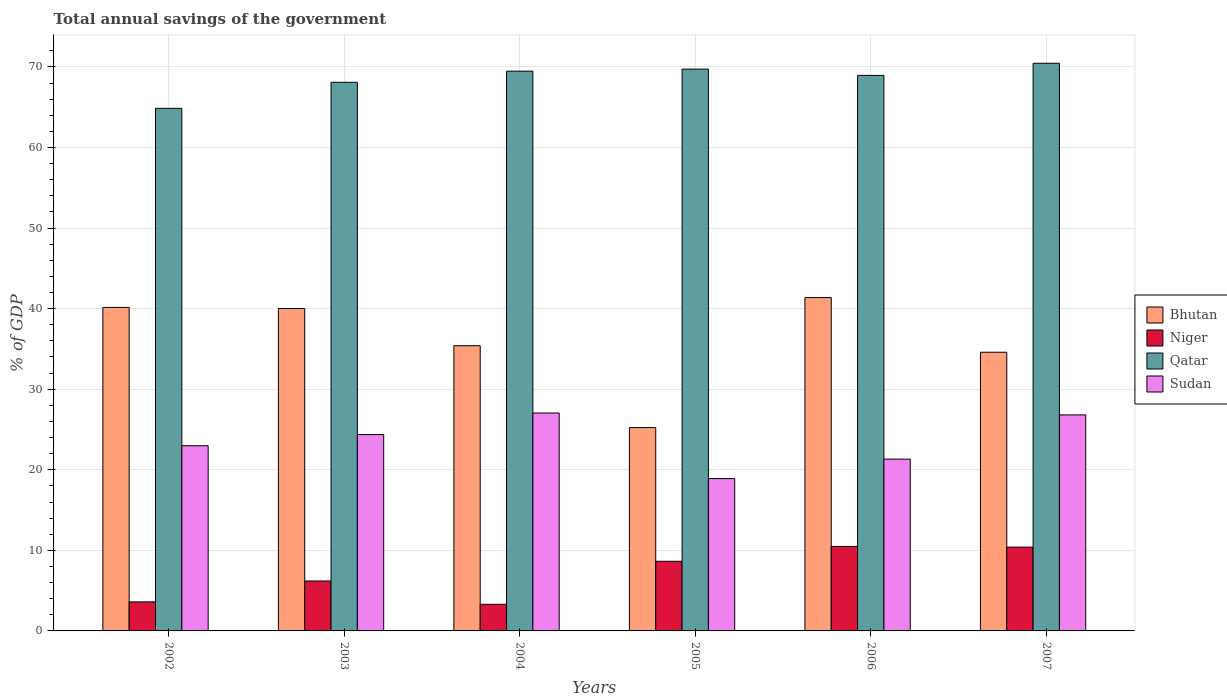Are the number of bars per tick equal to the number of legend labels?
Give a very brief answer. Yes. In how many cases, is the number of bars for a given year not equal to the number of legend labels?
Keep it short and to the point. 0. What is the total annual savings of the government in Bhutan in 2002?
Provide a short and direct response. 40.15. Across all years, what is the maximum total annual savings of the government in Niger?
Your response must be concise. 10.49. Across all years, what is the minimum total annual savings of the government in Qatar?
Keep it short and to the point. 64.86. In which year was the total annual savings of the government in Bhutan minimum?
Keep it short and to the point. 2005. What is the total total annual savings of the government in Niger in the graph?
Keep it short and to the point. 42.64. What is the difference between the total annual savings of the government in Sudan in 2002 and that in 2004?
Ensure brevity in your answer.  -4.06. What is the difference between the total annual savings of the government in Bhutan in 2007 and the total annual savings of the government in Sudan in 2003?
Offer a very short reply. 10.22. What is the average total annual savings of the government in Niger per year?
Keep it short and to the point. 7.11. In the year 2004, what is the difference between the total annual savings of the government in Sudan and total annual savings of the government in Bhutan?
Provide a short and direct response. -8.35. What is the ratio of the total annual savings of the government in Niger in 2004 to that in 2007?
Offer a very short reply. 0.32. Is the total annual savings of the government in Sudan in 2004 less than that in 2006?
Keep it short and to the point. No. Is the difference between the total annual savings of the government in Sudan in 2005 and 2007 greater than the difference between the total annual savings of the government in Bhutan in 2005 and 2007?
Offer a terse response. Yes. What is the difference between the highest and the second highest total annual savings of the government in Qatar?
Provide a succinct answer. 0.72. What is the difference between the highest and the lowest total annual savings of the government in Qatar?
Provide a succinct answer. 5.59. Is it the case that in every year, the sum of the total annual savings of the government in Niger and total annual savings of the government in Sudan is greater than the sum of total annual savings of the government in Qatar and total annual savings of the government in Bhutan?
Your response must be concise. No. What does the 3rd bar from the left in 2003 represents?
Give a very brief answer. Qatar. What does the 3rd bar from the right in 2004 represents?
Keep it short and to the point. Niger. How many bars are there?
Your answer should be compact. 24. Are all the bars in the graph horizontal?
Give a very brief answer. No. What is the difference between two consecutive major ticks on the Y-axis?
Ensure brevity in your answer.  10. How are the legend labels stacked?
Offer a very short reply. Vertical. What is the title of the graph?
Keep it short and to the point. Total annual savings of the government. Does "Mauritius" appear as one of the legend labels in the graph?
Your answer should be compact. No. What is the label or title of the Y-axis?
Your response must be concise. % of GDP. What is the % of GDP in Bhutan in 2002?
Ensure brevity in your answer.  40.15. What is the % of GDP of Niger in 2002?
Give a very brief answer. 3.6. What is the % of GDP in Qatar in 2002?
Keep it short and to the point. 64.86. What is the % of GDP in Sudan in 2002?
Offer a terse response. 22.98. What is the % of GDP in Bhutan in 2003?
Your answer should be compact. 40.01. What is the % of GDP in Niger in 2003?
Make the answer very short. 6.2. What is the % of GDP of Qatar in 2003?
Ensure brevity in your answer.  68.1. What is the % of GDP in Sudan in 2003?
Your answer should be very brief. 24.37. What is the % of GDP in Bhutan in 2004?
Give a very brief answer. 35.4. What is the % of GDP of Niger in 2004?
Provide a short and direct response. 3.31. What is the % of GDP in Qatar in 2004?
Offer a very short reply. 69.48. What is the % of GDP in Sudan in 2004?
Make the answer very short. 27.05. What is the % of GDP of Bhutan in 2005?
Offer a very short reply. 25.24. What is the % of GDP of Niger in 2005?
Offer a terse response. 8.64. What is the % of GDP in Qatar in 2005?
Give a very brief answer. 69.73. What is the % of GDP in Sudan in 2005?
Offer a terse response. 18.9. What is the % of GDP in Bhutan in 2006?
Give a very brief answer. 41.37. What is the % of GDP of Niger in 2006?
Provide a succinct answer. 10.49. What is the % of GDP of Qatar in 2006?
Keep it short and to the point. 68.95. What is the % of GDP in Sudan in 2006?
Make the answer very short. 21.32. What is the % of GDP in Bhutan in 2007?
Make the answer very short. 34.59. What is the % of GDP of Niger in 2007?
Provide a short and direct response. 10.4. What is the % of GDP of Qatar in 2007?
Offer a very short reply. 70.46. What is the % of GDP in Sudan in 2007?
Give a very brief answer. 26.81. Across all years, what is the maximum % of GDP of Bhutan?
Keep it short and to the point. 41.37. Across all years, what is the maximum % of GDP of Niger?
Offer a very short reply. 10.49. Across all years, what is the maximum % of GDP of Qatar?
Provide a succinct answer. 70.46. Across all years, what is the maximum % of GDP of Sudan?
Your answer should be compact. 27.05. Across all years, what is the minimum % of GDP of Bhutan?
Ensure brevity in your answer.  25.24. Across all years, what is the minimum % of GDP in Niger?
Ensure brevity in your answer.  3.31. Across all years, what is the minimum % of GDP in Qatar?
Offer a terse response. 64.86. Across all years, what is the minimum % of GDP in Sudan?
Make the answer very short. 18.9. What is the total % of GDP in Bhutan in the graph?
Ensure brevity in your answer.  216.76. What is the total % of GDP in Niger in the graph?
Provide a succinct answer. 42.64. What is the total % of GDP of Qatar in the graph?
Your answer should be compact. 411.58. What is the total % of GDP of Sudan in the graph?
Provide a succinct answer. 141.45. What is the difference between the % of GDP of Bhutan in 2002 and that in 2003?
Keep it short and to the point. 0.14. What is the difference between the % of GDP in Niger in 2002 and that in 2003?
Your answer should be very brief. -2.59. What is the difference between the % of GDP in Qatar in 2002 and that in 2003?
Offer a very short reply. -3.23. What is the difference between the % of GDP in Sudan in 2002 and that in 2003?
Your answer should be very brief. -1.39. What is the difference between the % of GDP in Bhutan in 2002 and that in 2004?
Offer a very short reply. 4.75. What is the difference between the % of GDP in Niger in 2002 and that in 2004?
Ensure brevity in your answer.  0.3. What is the difference between the % of GDP in Qatar in 2002 and that in 2004?
Your answer should be very brief. -4.61. What is the difference between the % of GDP in Sudan in 2002 and that in 2004?
Your response must be concise. -4.06. What is the difference between the % of GDP in Bhutan in 2002 and that in 2005?
Provide a short and direct response. 14.92. What is the difference between the % of GDP in Niger in 2002 and that in 2005?
Keep it short and to the point. -5.04. What is the difference between the % of GDP in Qatar in 2002 and that in 2005?
Offer a terse response. -4.87. What is the difference between the % of GDP of Sudan in 2002 and that in 2005?
Your response must be concise. 4.08. What is the difference between the % of GDP of Bhutan in 2002 and that in 2006?
Provide a short and direct response. -1.22. What is the difference between the % of GDP of Niger in 2002 and that in 2006?
Offer a terse response. -6.88. What is the difference between the % of GDP in Qatar in 2002 and that in 2006?
Keep it short and to the point. -4.09. What is the difference between the % of GDP of Sudan in 2002 and that in 2006?
Give a very brief answer. 1.66. What is the difference between the % of GDP of Bhutan in 2002 and that in 2007?
Give a very brief answer. 5.56. What is the difference between the % of GDP in Niger in 2002 and that in 2007?
Offer a terse response. -6.8. What is the difference between the % of GDP in Qatar in 2002 and that in 2007?
Keep it short and to the point. -5.59. What is the difference between the % of GDP in Sudan in 2002 and that in 2007?
Offer a terse response. -3.83. What is the difference between the % of GDP in Bhutan in 2003 and that in 2004?
Your answer should be very brief. 4.61. What is the difference between the % of GDP of Niger in 2003 and that in 2004?
Your response must be concise. 2.89. What is the difference between the % of GDP of Qatar in 2003 and that in 2004?
Give a very brief answer. -1.38. What is the difference between the % of GDP in Sudan in 2003 and that in 2004?
Provide a succinct answer. -2.67. What is the difference between the % of GDP in Bhutan in 2003 and that in 2005?
Your response must be concise. 14.78. What is the difference between the % of GDP of Niger in 2003 and that in 2005?
Your answer should be compact. -2.45. What is the difference between the % of GDP of Qatar in 2003 and that in 2005?
Your answer should be very brief. -1.64. What is the difference between the % of GDP in Sudan in 2003 and that in 2005?
Offer a terse response. 5.47. What is the difference between the % of GDP in Bhutan in 2003 and that in 2006?
Keep it short and to the point. -1.36. What is the difference between the % of GDP of Niger in 2003 and that in 2006?
Ensure brevity in your answer.  -4.29. What is the difference between the % of GDP of Qatar in 2003 and that in 2006?
Make the answer very short. -0.86. What is the difference between the % of GDP in Sudan in 2003 and that in 2006?
Keep it short and to the point. 3.05. What is the difference between the % of GDP of Bhutan in 2003 and that in 2007?
Your response must be concise. 5.42. What is the difference between the % of GDP in Niger in 2003 and that in 2007?
Your answer should be very brief. -4.2. What is the difference between the % of GDP in Qatar in 2003 and that in 2007?
Keep it short and to the point. -2.36. What is the difference between the % of GDP in Sudan in 2003 and that in 2007?
Your answer should be very brief. -2.44. What is the difference between the % of GDP in Bhutan in 2004 and that in 2005?
Offer a terse response. 10.16. What is the difference between the % of GDP in Niger in 2004 and that in 2005?
Your answer should be compact. -5.34. What is the difference between the % of GDP in Qatar in 2004 and that in 2005?
Your answer should be very brief. -0.26. What is the difference between the % of GDP in Sudan in 2004 and that in 2005?
Offer a terse response. 8.14. What is the difference between the % of GDP in Bhutan in 2004 and that in 2006?
Your answer should be very brief. -5.97. What is the difference between the % of GDP of Niger in 2004 and that in 2006?
Your answer should be compact. -7.18. What is the difference between the % of GDP in Qatar in 2004 and that in 2006?
Offer a terse response. 0.52. What is the difference between the % of GDP in Sudan in 2004 and that in 2006?
Your answer should be compact. 5.72. What is the difference between the % of GDP in Bhutan in 2004 and that in 2007?
Your answer should be compact. 0.81. What is the difference between the % of GDP in Niger in 2004 and that in 2007?
Your answer should be compact. -7.1. What is the difference between the % of GDP of Qatar in 2004 and that in 2007?
Your answer should be very brief. -0.98. What is the difference between the % of GDP of Sudan in 2004 and that in 2007?
Offer a very short reply. 0.23. What is the difference between the % of GDP in Bhutan in 2005 and that in 2006?
Your answer should be compact. -16.14. What is the difference between the % of GDP of Niger in 2005 and that in 2006?
Give a very brief answer. -1.84. What is the difference between the % of GDP in Qatar in 2005 and that in 2006?
Keep it short and to the point. 0.78. What is the difference between the % of GDP in Sudan in 2005 and that in 2006?
Your response must be concise. -2.42. What is the difference between the % of GDP in Bhutan in 2005 and that in 2007?
Offer a very short reply. -9.35. What is the difference between the % of GDP in Niger in 2005 and that in 2007?
Keep it short and to the point. -1.76. What is the difference between the % of GDP in Qatar in 2005 and that in 2007?
Keep it short and to the point. -0.72. What is the difference between the % of GDP of Sudan in 2005 and that in 2007?
Your answer should be compact. -7.91. What is the difference between the % of GDP of Bhutan in 2006 and that in 2007?
Give a very brief answer. 6.78. What is the difference between the % of GDP in Niger in 2006 and that in 2007?
Give a very brief answer. 0.09. What is the difference between the % of GDP of Qatar in 2006 and that in 2007?
Offer a terse response. -1.5. What is the difference between the % of GDP of Sudan in 2006 and that in 2007?
Your response must be concise. -5.49. What is the difference between the % of GDP of Bhutan in 2002 and the % of GDP of Niger in 2003?
Your answer should be very brief. 33.95. What is the difference between the % of GDP in Bhutan in 2002 and the % of GDP in Qatar in 2003?
Your answer should be compact. -27.94. What is the difference between the % of GDP of Bhutan in 2002 and the % of GDP of Sudan in 2003?
Give a very brief answer. 15.78. What is the difference between the % of GDP in Niger in 2002 and the % of GDP in Qatar in 2003?
Your answer should be very brief. -64.49. What is the difference between the % of GDP in Niger in 2002 and the % of GDP in Sudan in 2003?
Offer a very short reply. -20.77. What is the difference between the % of GDP of Qatar in 2002 and the % of GDP of Sudan in 2003?
Keep it short and to the point. 40.49. What is the difference between the % of GDP in Bhutan in 2002 and the % of GDP in Niger in 2004?
Keep it short and to the point. 36.85. What is the difference between the % of GDP in Bhutan in 2002 and the % of GDP in Qatar in 2004?
Offer a terse response. -29.32. What is the difference between the % of GDP of Bhutan in 2002 and the % of GDP of Sudan in 2004?
Provide a short and direct response. 13.11. What is the difference between the % of GDP of Niger in 2002 and the % of GDP of Qatar in 2004?
Make the answer very short. -65.87. What is the difference between the % of GDP of Niger in 2002 and the % of GDP of Sudan in 2004?
Your response must be concise. -23.44. What is the difference between the % of GDP in Qatar in 2002 and the % of GDP in Sudan in 2004?
Keep it short and to the point. 37.82. What is the difference between the % of GDP in Bhutan in 2002 and the % of GDP in Niger in 2005?
Keep it short and to the point. 31.51. What is the difference between the % of GDP of Bhutan in 2002 and the % of GDP of Qatar in 2005?
Provide a short and direct response. -29.58. What is the difference between the % of GDP of Bhutan in 2002 and the % of GDP of Sudan in 2005?
Your response must be concise. 21.25. What is the difference between the % of GDP in Niger in 2002 and the % of GDP in Qatar in 2005?
Ensure brevity in your answer.  -66.13. What is the difference between the % of GDP of Niger in 2002 and the % of GDP of Sudan in 2005?
Your answer should be compact. -15.3. What is the difference between the % of GDP in Qatar in 2002 and the % of GDP in Sudan in 2005?
Ensure brevity in your answer.  45.96. What is the difference between the % of GDP in Bhutan in 2002 and the % of GDP in Niger in 2006?
Offer a terse response. 29.67. What is the difference between the % of GDP in Bhutan in 2002 and the % of GDP in Qatar in 2006?
Your response must be concise. -28.8. What is the difference between the % of GDP of Bhutan in 2002 and the % of GDP of Sudan in 2006?
Give a very brief answer. 18.83. What is the difference between the % of GDP of Niger in 2002 and the % of GDP of Qatar in 2006?
Provide a succinct answer. -65.35. What is the difference between the % of GDP in Niger in 2002 and the % of GDP in Sudan in 2006?
Provide a short and direct response. -17.72. What is the difference between the % of GDP in Qatar in 2002 and the % of GDP in Sudan in 2006?
Ensure brevity in your answer.  43.54. What is the difference between the % of GDP of Bhutan in 2002 and the % of GDP of Niger in 2007?
Ensure brevity in your answer.  29.75. What is the difference between the % of GDP of Bhutan in 2002 and the % of GDP of Qatar in 2007?
Ensure brevity in your answer.  -30.3. What is the difference between the % of GDP of Bhutan in 2002 and the % of GDP of Sudan in 2007?
Give a very brief answer. 13.34. What is the difference between the % of GDP of Niger in 2002 and the % of GDP of Qatar in 2007?
Keep it short and to the point. -66.85. What is the difference between the % of GDP of Niger in 2002 and the % of GDP of Sudan in 2007?
Your answer should be very brief. -23.21. What is the difference between the % of GDP in Qatar in 2002 and the % of GDP in Sudan in 2007?
Give a very brief answer. 38.05. What is the difference between the % of GDP in Bhutan in 2003 and the % of GDP in Niger in 2004?
Ensure brevity in your answer.  36.71. What is the difference between the % of GDP in Bhutan in 2003 and the % of GDP in Qatar in 2004?
Keep it short and to the point. -29.46. What is the difference between the % of GDP in Bhutan in 2003 and the % of GDP in Sudan in 2004?
Ensure brevity in your answer.  12.97. What is the difference between the % of GDP of Niger in 2003 and the % of GDP of Qatar in 2004?
Offer a very short reply. -63.28. What is the difference between the % of GDP in Niger in 2003 and the % of GDP in Sudan in 2004?
Provide a succinct answer. -20.85. What is the difference between the % of GDP in Qatar in 2003 and the % of GDP in Sudan in 2004?
Keep it short and to the point. 41.05. What is the difference between the % of GDP of Bhutan in 2003 and the % of GDP of Niger in 2005?
Provide a short and direct response. 31.37. What is the difference between the % of GDP of Bhutan in 2003 and the % of GDP of Qatar in 2005?
Your answer should be compact. -29.72. What is the difference between the % of GDP in Bhutan in 2003 and the % of GDP in Sudan in 2005?
Provide a short and direct response. 21.11. What is the difference between the % of GDP of Niger in 2003 and the % of GDP of Qatar in 2005?
Your answer should be very brief. -63.53. What is the difference between the % of GDP in Niger in 2003 and the % of GDP in Sudan in 2005?
Offer a terse response. -12.71. What is the difference between the % of GDP in Qatar in 2003 and the % of GDP in Sudan in 2005?
Offer a very short reply. 49.19. What is the difference between the % of GDP of Bhutan in 2003 and the % of GDP of Niger in 2006?
Provide a short and direct response. 29.52. What is the difference between the % of GDP in Bhutan in 2003 and the % of GDP in Qatar in 2006?
Give a very brief answer. -28.94. What is the difference between the % of GDP in Bhutan in 2003 and the % of GDP in Sudan in 2006?
Offer a terse response. 18.69. What is the difference between the % of GDP in Niger in 2003 and the % of GDP in Qatar in 2006?
Provide a short and direct response. -62.76. What is the difference between the % of GDP in Niger in 2003 and the % of GDP in Sudan in 2006?
Provide a succinct answer. -15.13. What is the difference between the % of GDP of Qatar in 2003 and the % of GDP of Sudan in 2006?
Provide a succinct answer. 46.77. What is the difference between the % of GDP of Bhutan in 2003 and the % of GDP of Niger in 2007?
Offer a terse response. 29.61. What is the difference between the % of GDP in Bhutan in 2003 and the % of GDP in Qatar in 2007?
Provide a succinct answer. -30.45. What is the difference between the % of GDP of Bhutan in 2003 and the % of GDP of Sudan in 2007?
Ensure brevity in your answer.  13.2. What is the difference between the % of GDP in Niger in 2003 and the % of GDP in Qatar in 2007?
Offer a terse response. -64.26. What is the difference between the % of GDP of Niger in 2003 and the % of GDP of Sudan in 2007?
Offer a very short reply. -20.61. What is the difference between the % of GDP of Qatar in 2003 and the % of GDP of Sudan in 2007?
Provide a succinct answer. 41.28. What is the difference between the % of GDP of Bhutan in 2004 and the % of GDP of Niger in 2005?
Provide a succinct answer. 26.76. What is the difference between the % of GDP in Bhutan in 2004 and the % of GDP in Qatar in 2005?
Your answer should be very brief. -34.33. What is the difference between the % of GDP in Bhutan in 2004 and the % of GDP in Sudan in 2005?
Your answer should be very brief. 16.5. What is the difference between the % of GDP of Niger in 2004 and the % of GDP of Qatar in 2005?
Offer a very short reply. -66.43. What is the difference between the % of GDP of Niger in 2004 and the % of GDP of Sudan in 2005?
Your answer should be compact. -15.6. What is the difference between the % of GDP of Qatar in 2004 and the % of GDP of Sudan in 2005?
Provide a short and direct response. 50.57. What is the difference between the % of GDP of Bhutan in 2004 and the % of GDP of Niger in 2006?
Make the answer very short. 24.91. What is the difference between the % of GDP of Bhutan in 2004 and the % of GDP of Qatar in 2006?
Ensure brevity in your answer.  -33.55. What is the difference between the % of GDP of Bhutan in 2004 and the % of GDP of Sudan in 2006?
Offer a very short reply. 14.08. What is the difference between the % of GDP in Niger in 2004 and the % of GDP in Qatar in 2006?
Provide a short and direct response. -65.65. What is the difference between the % of GDP of Niger in 2004 and the % of GDP of Sudan in 2006?
Give a very brief answer. -18.02. What is the difference between the % of GDP in Qatar in 2004 and the % of GDP in Sudan in 2006?
Your answer should be compact. 48.15. What is the difference between the % of GDP of Bhutan in 2004 and the % of GDP of Niger in 2007?
Offer a terse response. 25. What is the difference between the % of GDP in Bhutan in 2004 and the % of GDP in Qatar in 2007?
Your answer should be compact. -35.06. What is the difference between the % of GDP of Bhutan in 2004 and the % of GDP of Sudan in 2007?
Give a very brief answer. 8.59. What is the difference between the % of GDP in Niger in 2004 and the % of GDP in Qatar in 2007?
Your answer should be compact. -67.15. What is the difference between the % of GDP of Niger in 2004 and the % of GDP of Sudan in 2007?
Provide a short and direct response. -23.51. What is the difference between the % of GDP in Qatar in 2004 and the % of GDP in Sudan in 2007?
Your answer should be very brief. 42.66. What is the difference between the % of GDP of Bhutan in 2005 and the % of GDP of Niger in 2006?
Your answer should be compact. 14.75. What is the difference between the % of GDP in Bhutan in 2005 and the % of GDP in Qatar in 2006?
Make the answer very short. -43.72. What is the difference between the % of GDP in Bhutan in 2005 and the % of GDP in Sudan in 2006?
Your answer should be compact. 3.91. What is the difference between the % of GDP of Niger in 2005 and the % of GDP of Qatar in 2006?
Offer a very short reply. -60.31. What is the difference between the % of GDP of Niger in 2005 and the % of GDP of Sudan in 2006?
Keep it short and to the point. -12.68. What is the difference between the % of GDP of Qatar in 2005 and the % of GDP of Sudan in 2006?
Offer a terse response. 48.41. What is the difference between the % of GDP of Bhutan in 2005 and the % of GDP of Niger in 2007?
Keep it short and to the point. 14.83. What is the difference between the % of GDP of Bhutan in 2005 and the % of GDP of Qatar in 2007?
Your answer should be very brief. -45.22. What is the difference between the % of GDP in Bhutan in 2005 and the % of GDP in Sudan in 2007?
Make the answer very short. -1.58. What is the difference between the % of GDP of Niger in 2005 and the % of GDP of Qatar in 2007?
Your response must be concise. -61.81. What is the difference between the % of GDP of Niger in 2005 and the % of GDP of Sudan in 2007?
Your answer should be very brief. -18.17. What is the difference between the % of GDP of Qatar in 2005 and the % of GDP of Sudan in 2007?
Ensure brevity in your answer.  42.92. What is the difference between the % of GDP of Bhutan in 2006 and the % of GDP of Niger in 2007?
Your answer should be very brief. 30.97. What is the difference between the % of GDP of Bhutan in 2006 and the % of GDP of Qatar in 2007?
Provide a short and direct response. -29.09. What is the difference between the % of GDP in Bhutan in 2006 and the % of GDP in Sudan in 2007?
Provide a succinct answer. 14.56. What is the difference between the % of GDP in Niger in 2006 and the % of GDP in Qatar in 2007?
Offer a terse response. -59.97. What is the difference between the % of GDP of Niger in 2006 and the % of GDP of Sudan in 2007?
Keep it short and to the point. -16.32. What is the difference between the % of GDP of Qatar in 2006 and the % of GDP of Sudan in 2007?
Give a very brief answer. 42.14. What is the average % of GDP of Bhutan per year?
Keep it short and to the point. 36.13. What is the average % of GDP in Niger per year?
Provide a succinct answer. 7.11. What is the average % of GDP in Qatar per year?
Your answer should be very brief. 68.6. What is the average % of GDP of Sudan per year?
Make the answer very short. 23.57. In the year 2002, what is the difference between the % of GDP in Bhutan and % of GDP in Niger?
Offer a very short reply. 36.55. In the year 2002, what is the difference between the % of GDP in Bhutan and % of GDP in Qatar?
Offer a terse response. -24.71. In the year 2002, what is the difference between the % of GDP of Bhutan and % of GDP of Sudan?
Your response must be concise. 17.17. In the year 2002, what is the difference between the % of GDP in Niger and % of GDP in Qatar?
Make the answer very short. -61.26. In the year 2002, what is the difference between the % of GDP in Niger and % of GDP in Sudan?
Provide a succinct answer. -19.38. In the year 2002, what is the difference between the % of GDP in Qatar and % of GDP in Sudan?
Provide a short and direct response. 41.88. In the year 2003, what is the difference between the % of GDP in Bhutan and % of GDP in Niger?
Give a very brief answer. 33.81. In the year 2003, what is the difference between the % of GDP in Bhutan and % of GDP in Qatar?
Your response must be concise. -28.08. In the year 2003, what is the difference between the % of GDP of Bhutan and % of GDP of Sudan?
Provide a short and direct response. 15.64. In the year 2003, what is the difference between the % of GDP of Niger and % of GDP of Qatar?
Keep it short and to the point. -61.9. In the year 2003, what is the difference between the % of GDP of Niger and % of GDP of Sudan?
Your response must be concise. -18.18. In the year 2003, what is the difference between the % of GDP in Qatar and % of GDP in Sudan?
Provide a short and direct response. 43.72. In the year 2004, what is the difference between the % of GDP of Bhutan and % of GDP of Niger?
Provide a succinct answer. 32.09. In the year 2004, what is the difference between the % of GDP in Bhutan and % of GDP in Qatar?
Give a very brief answer. -34.07. In the year 2004, what is the difference between the % of GDP of Bhutan and % of GDP of Sudan?
Your answer should be compact. 8.35. In the year 2004, what is the difference between the % of GDP in Niger and % of GDP in Qatar?
Give a very brief answer. -66.17. In the year 2004, what is the difference between the % of GDP in Niger and % of GDP in Sudan?
Offer a very short reply. -23.74. In the year 2004, what is the difference between the % of GDP of Qatar and % of GDP of Sudan?
Your answer should be compact. 42.43. In the year 2005, what is the difference between the % of GDP of Bhutan and % of GDP of Niger?
Ensure brevity in your answer.  16.59. In the year 2005, what is the difference between the % of GDP of Bhutan and % of GDP of Qatar?
Ensure brevity in your answer.  -44.5. In the year 2005, what is the difference between the % of GDP of Bhutan and % of GDP of Sudan?
Ensure brevity in your answer.  6.33. In the year 2005, what is the difference between the % of GDP in Niger and % of GDP in Qatar?
Offer a terse response. -61.09. In the year 2005, what is the difference between the % of GDP in Niger and % of GDP in Sudan?
Your response must be concise. -10.26. In the year 2005, what is the difference between the % of GDP in Qatar and % of GDP in Sudan?
Your answer should be compact. 50.83. In the year 2006, what is the difference between the % of GDP in Bhutan and % of GDP in Niger?
Keep it short and to the point. 30.88. In the year 2006, what is the difference between the % of GDP of Bhutan and % of GDP of Qatar?
Your answer should be very brief. -27.58. In the year 2006, what is the difference between the % of GDP in Bhutan and % of GDP in Sudan?
Offer a very short reply. 20.05. In the year 2006, what is the difference between the % of GDP in Niger and % of GDP in Qatar?
Ensure brevity in your answer.  -58.47. In the year 2006, what is the difference between the % of GDP of Niger and % of GDP of Sudan?
Provide a succinct answer. -10.84. In the year 2006, what is the difference between the % of GDP in Qatar and % of GDP in Sudan?
Offer a very short reply. 47.63. In the year 2007, what is the difference between the % of GDP in Bhutan and % of GDP in Niger?
Make the answer very short. 24.19. In the year 2007, what is the difference between the % of GDP of Bhutan and % of GDP of Qatar?
Keep it short and to the point. -35.87. In the year 2007, what is the difference between the % of GDP of Bhutan and % of GDP of Sudan?
Provide a succinct answer. 7.78. In the year 2007, what is the difference between the % of GDP of Niger and % of GDP of Qatar?
Your response must be concise. -60.06. In the year 2007, what is the difference between the % of GDP in Niger and % of GDP in Sudan?
Your response must be concise. -16.41. In the year 2007, what is the difference between the % of GDP of Qatar and % of GDP of Sudan?
Provide a succinct answer. 43.65. What is the ratio of the % of GDP of Niger in 2002 to that in 2003?
Offer a very short reply. 0.58. What is the ratio of the % of GDP in Qatar in 2002 to that in 2003?
Give a very brief answer. 0.95. What is the ratio of the % of GDP of Sudan in 2002 to that in 2003?
Offer a very short reply. 0.94. What is the ratio of the % of GDP of Bhutan in 2002 to that in 2004?
Ensure brevity in your answer.  1.13. What is the ratio of the % of GDP in Niger in 2002 to that in 2004?
Keep it short and to the point. 1.09. What is the ratio of the % of GDP in Qatar in 2002 to that in 2004?
Ensure brevity in your answer.  0.93. What is the ratio of the % of GDP of Sudan in 2002 to that in 2004?
Make the answer very short. 0.85. What is the ratio of the % of GDP of Bhutan in 2002 to that in 2005?
Provide a succinct answer. 1.59. What is the ratio of the % of GDP of Niger in 2002 to that in 2005?
Make the answer very short. 0.42. What is the ratio of the % of GDP of Qatar in 2002 to that in 2005?
Your answer should be compact. 0.93. What is the ratio of the % of GDP of Sudan in 2002 to that in 2005?
Make the answer very short. 1.22. What is the ratio of the % of GDP in Bhutan in 2002 to that in 2006?
Your answer should be compact. 0.97. What is the ratio of the % of GDP in Niger in 2002 to that in 2006?
Keep it short and to the point. 0.34. What is the ratio of the % of GDP of Qatar in 2002 to that in 2006?
Provide a succinct answer. 0.94. What is the ratio of the % of GDP of Sudan in 2002 to that in 2006?
Provide a succinct answer. 1.08. What is the ratio of the % of GDP of Bhutan in 2002 to that in 2007?
Provide a short and direct response. 1.16. What is the ratio of the % of GDP of Niger in 2002 to that in 2007?
Offer a very short reply. 0.35. What is the ratio of the % of GDP in Qatar in 2002 to that in 2007?
Keep it short and to the point. 0.92. What is the ratio of the % of GDP of Sudan in 2002 to that in 2007?
Keep it short and to the point. 0.86. What is the ratio of the % of GDP of Bhutan in 2003 to that in 2004?
Your answer should be very brief. 1.13. What is the ratio of the % of GDP of Niger in 2003 to that in 2004?
Give a very brief answer. 1.87. What is the ratio of the % of GDP of Qatar in 2003 to that in 2004?
Make the answer very short. 0.98. What is the ratio of the % of GDP of Sudan in 2003 to that in 2004?
Provide a short and direct response. 0.9. What is the ratio of the % of GDP in Bhutan in 2003 to that in 2005?
Your answer should be very brief. 1.59. What is the ratio of the % of GDP of Niger in 2003 to that in 2005?
Make the answer very short. 0.72. What is the ratio of the % of GDP of Qatar in 2003 to that in 2005?
Give a very brief answer. 0.98. What is the ratio of the % of GDP of Sudan in 2003 to that in 2005?
Your response must be concise. 1.29. What is the ratio of the % of GDP in Bhutan in 2003 to that in 2006?
Provide a succinct answer. 0.97. What is the ratio of the % of GDP in Niger in 2003 to that in 2006?
Ensure brevity in your answer.  0.59. What is the ratio of the % of GDP in Qatar in 2003 to that in 2006?
Make the answer very short. 0.99. What is the ratio of the % of GDP in Bhutan in 2003 to that in 2007?
Ensure brevity in your answer.  1.16. What is the ratio of the % of GDP of Niger in 2003 to that in 2007?
Keep it short and to the point. 0.6. What is the ratio of the % of GDP of Qatar in 2003 to that in 2007?
Give a very brief answer. 0.97. What is the ratio of the % of GDP of Sudan in 2003 to that in 2007?
Your answer should be compact. 0.91. What is the ratio of the % of GDP of Bhutan in 2004 to that in 2005?
Offer a terse response. 1.4. What is the ratio of the % of GDP of Niger in 2004 to that in 2005?
Ensure brevity in your answer.  0.38. What is the ratio of the % of GDP of Qatar in 2004 to that in 2005?
Your response must be concise. 1. What is the ratio of the % of GDP of Sudan in 2004 to that in 2005?
Ensure brevity in your answer.  1.43. What is the ratio of the % of GDP in Bhutan in 2004 to that in 2006?
Make the answer very short. 0.86. What is the ratio of the % of GDP of Niger in 2004 to that in 2006?
Ensure brevity in your answer.  0.32. What is the ratio of the % of GDP of Qatar in 2004 to that in 2006?
Ensure brevity in your answer.  1.01. What is the ratio of the % of GDP in Sudan in 2004 to that in 2006?
Your response must be concise. 1.27. What is the ratio of the % of GDP of Bhutan in 2004 to that in 2007?
Make the answer very short. 1.02. What is the ratio of the % of GDP of Niger in 2004 to that in 2007?
Keep it short and to the point. 0.32. What is the ratio of the % of GDP of Qatar in 2004 to that in 2007?
Keep it short and to the point. 0.99. What is the ratio of the % of GDP of Sudan in 2004 to that in 2007?
Your answer should be very brief. 1.01. What is the ratio of the % of GDP in Bhutan in 2005 to that in 2006?
Offer a very short reply. 0.61. What is the ratio of the % of GDP of Niger in 2005 to that in 2006?
Offer a very short reply. 0.82. What is the ratio of the % of GDP in Qatar in 2005 to that in 2006?
Ensure brevity in your answer.  1.01. What is the ratio of the % of GDP of Sudan in 2005 to that in 2006?
Your answer should be compact. 0.89. What is the ratio of the % of GDP in Bhutan in 2005 to that in 2007?
Make the answer very short. 0.73. What is the ratio of the % of GDP in Niger in 2005 to that in 2007?
Provide a succinct answer. 0.83. What is the ratio of the % of GDP of Qatar in 2005 to that in 2007?
Provide a short and direct response. 0.99. What is the ratio of the % of GDP of Sudan in 2005 to that in 2007?
Your answer should be compact. 0.71. What is the ratio of the % of GDP of Bhutan in 2006 to that in 2007?
Provide a short and direct response. 1.2. What is the ratio of the % of GDP of Niger in 2006 to that in 2007?
Keep it short and to the point. 1.01. What is the ratio of the % of GDP in Qatar in 2006 to that in 2007?
Give a very brief answer. 0.98. What is the ratio of the % of GDP of Sudan in 2006 to that in 2007?
Offer a very short reply. 0.8. What is the difference between the highest and the second highest % of GDP of Bhutan?
Ensure brevity in your answer.  1.22. What is the difference between the highest and the second highest % of GDP in Niger?
Provide a succinct answer. 0.09. What is the difference between the highest and the second highest % of GDP of Qatar?
Your answer should be compact. 0.72. What is the difference between the highest and the second highest % of GDP in Sudan?
Your answer should be compact. 0.23. What is the difference between the highest and the lowest % of GDP in Bhutan?
Make the answer very short. 16.14. What is the difference between the highest and the lowest % of GDP in Niger?
Offer a very short reply. 7.18. What is the difference between the highest and the lowest % of GDP in Qatar?
Make the answer very short. 5.59. What is the difference between the highest and the lowest % of GDP of Sudan?
Ensure brevity in your answer.  8.14. 